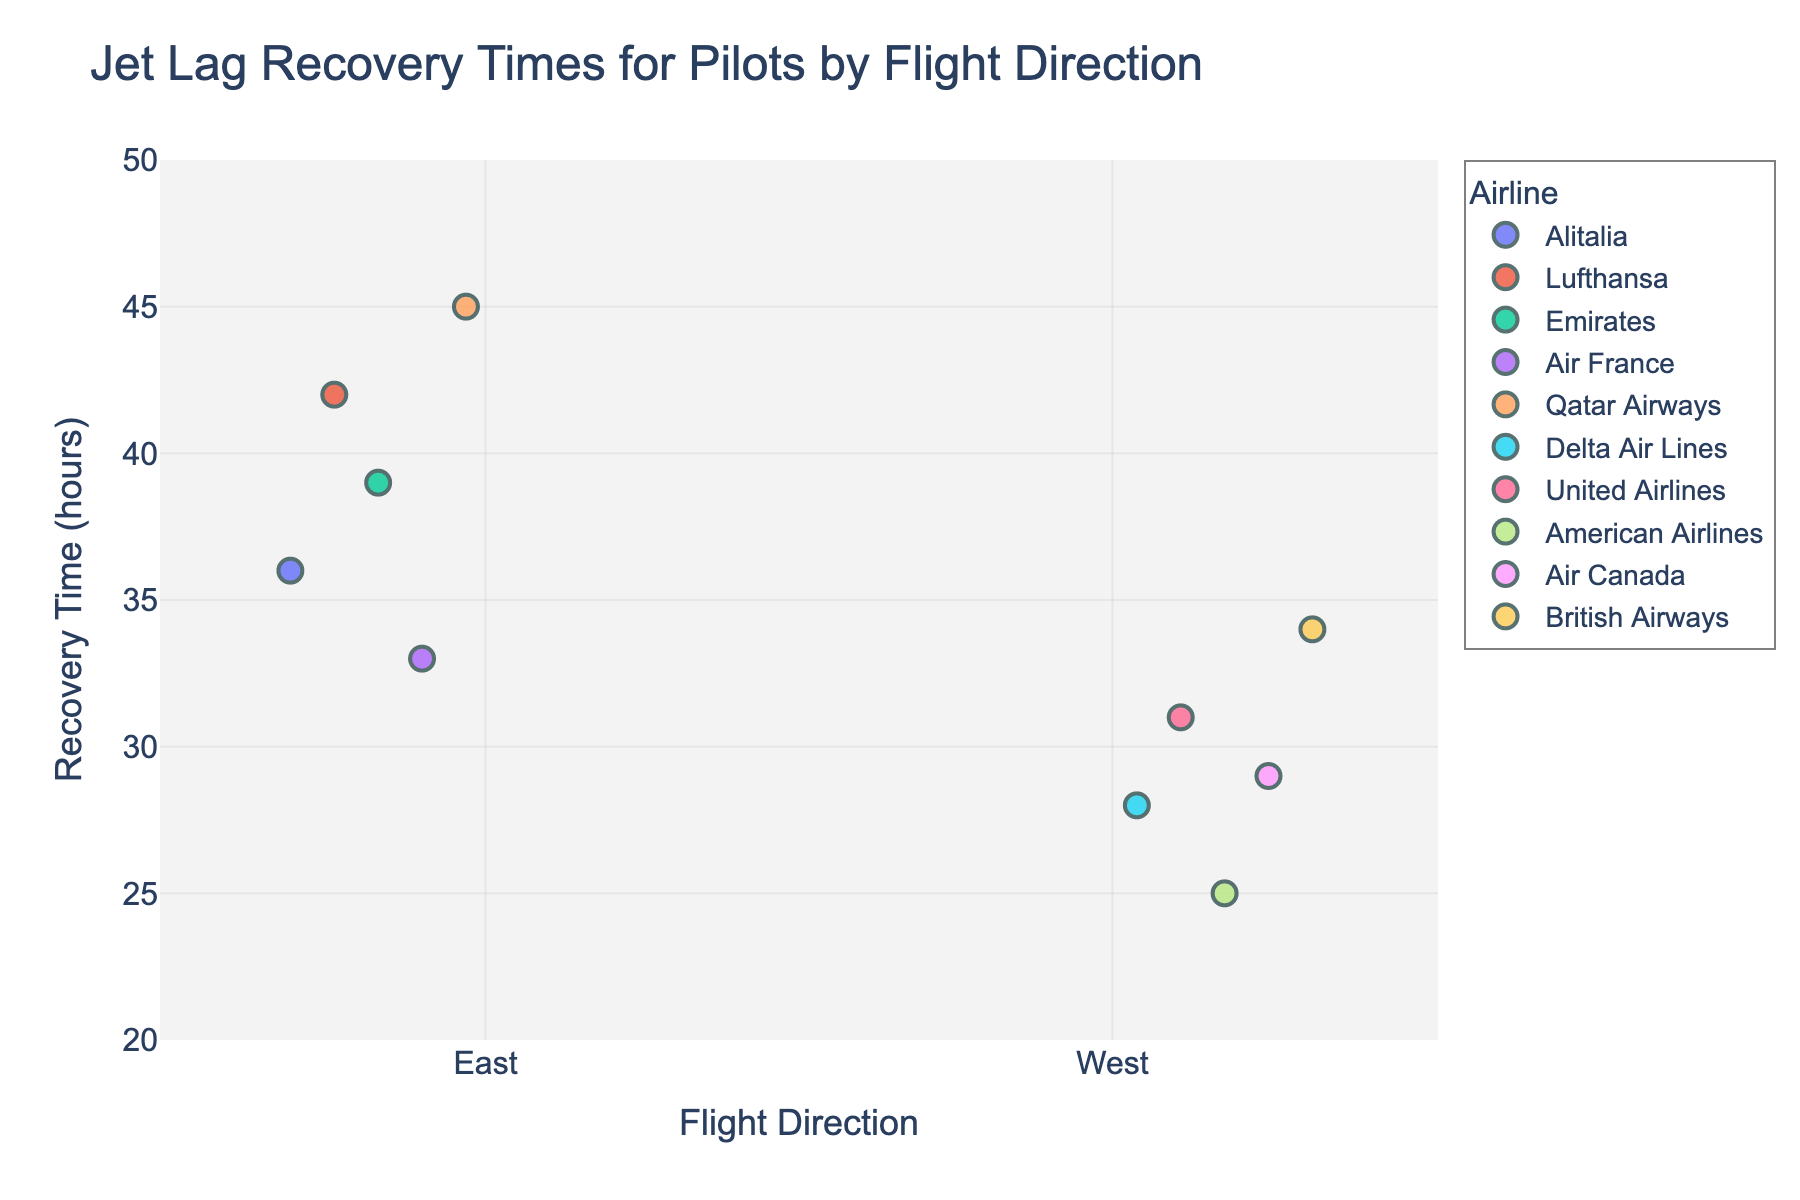Which flight direction has the longest jet lag recovery time? Compare the recovery times for East and West directions, and find the highest value. East has Qatar Airways with 45 hours recovery time, which is the longest.
Answer: East Which flight direction generally shows shorter recovery times for pilots? Compare the majority of recovery times for both directions. For East, values range widely including high ones, while West values are more clustered and lower.
Answer: West What is the average recovery time for flights going East? Add the recovery times for flights going East and divide by the number of entries: (36 + 42 + 39 + 33 + 45) / 5 = 39 hours
Answer: 39 hours Which airline has the shortest recovery time for West-bound flights? Identify the smallest recovery time among West-bound flights, which is American Airlines with 25 hours.
Answer: American Airlines Is there any overlap in recovery times between East and West-bound flights? Check if there are any identical or common recovery times in both directions. The range for East is 33-45 hours, and for West is 25-34 hours, so yes, there is an overlap.
Answer: Yes What is the difference between the maximum recovery times of East-bound and West-bound flights? Find the maximum recovery time for each direction and calculate the difference: 45 (East) - 34 (West) = 11 hours
Answer: 11 hours Which direction has the highest concentration of recovery times below 35 hours? Examine recovery times below 35 hours for both directions. West-bound flights have three out of five data points below 35 hours.
Answer: West How does Air France's recovery time compare to the average for East-bound flights? Air France has a recovery time of 33 hours. The average for East is 39 hours. Subtract Air France’s time from the average: 39 - 33 = 6 hours shorter.
Answer: 6 hours shorter Which airline shows the highest recovery time among East-bound flights? Identify the airline with the highest value in the East direction, which is Qatar Airways with 45 hours.
Answer: Qatar Airways What is the combined average recovery time for both East and West-bound flights? Add all the recovery times from both directions and divide by the total number of entries: (36 + 42 + 39 + 33 + 45 + 28 + 31 + 25 + 29 + 34) / 10 = 34.2 hours
Answer: 34.2 hours 